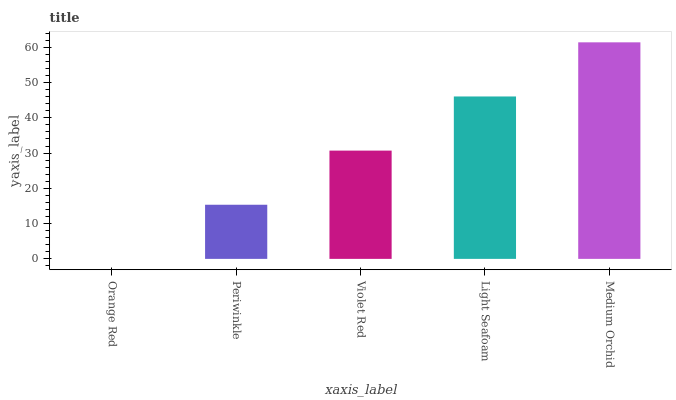Is Orange Red the minimum?
Answer yes or no. Yes. Is Medium Orchid the maximum?
Answer yes or no. Yes. Is Periwinkle the minimum?
Answer yes or no. No. Is Periwinkle the maximum?
Answer yes or no. No. Is Periwinkle greater than Orange Red?
Answer yes or no. Yes. Is Orange Red less than Periwinkle?
Answer yes or no. Yes. Is Orange Red greater than Periwinkle?
Answer yes or no. No. Is Periwinkle less than Orange Red?
Answer yes or no. No. Is Violet Red the high median?
Answer yes or no. Yes. Is Violet Red the low median?
Answer yes or no. Yes. Is Light Seafoam the high median?
Answer yes or no. No. Is Periwinkle the low median?
Answer yes or no. No. 